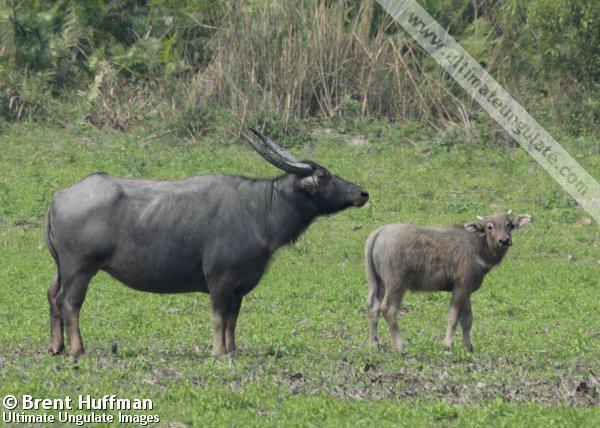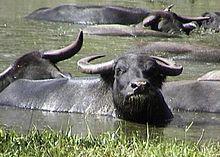The first image is the image on the left, the second image is the image on the right. Examine the images to the left and right. Is the description "One of the images contains one baby water buffalo." accurate? Answer yes or no. Yes. 